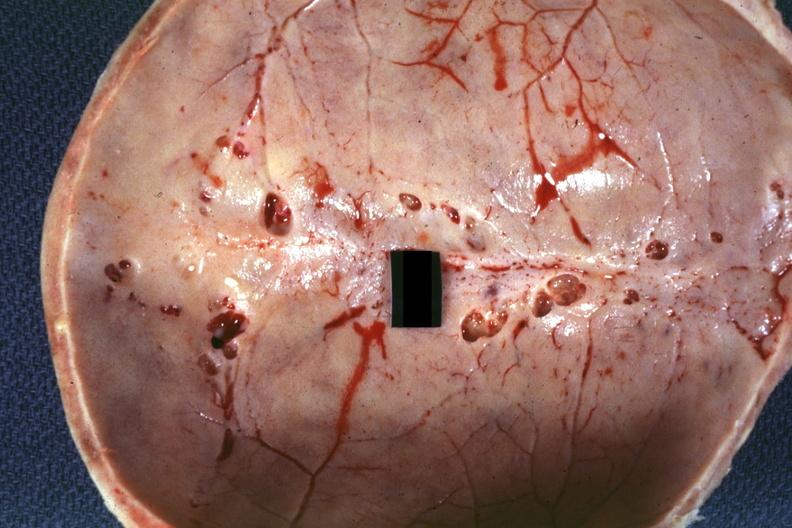s history present?
Answer the question using a single word or phrase. No 